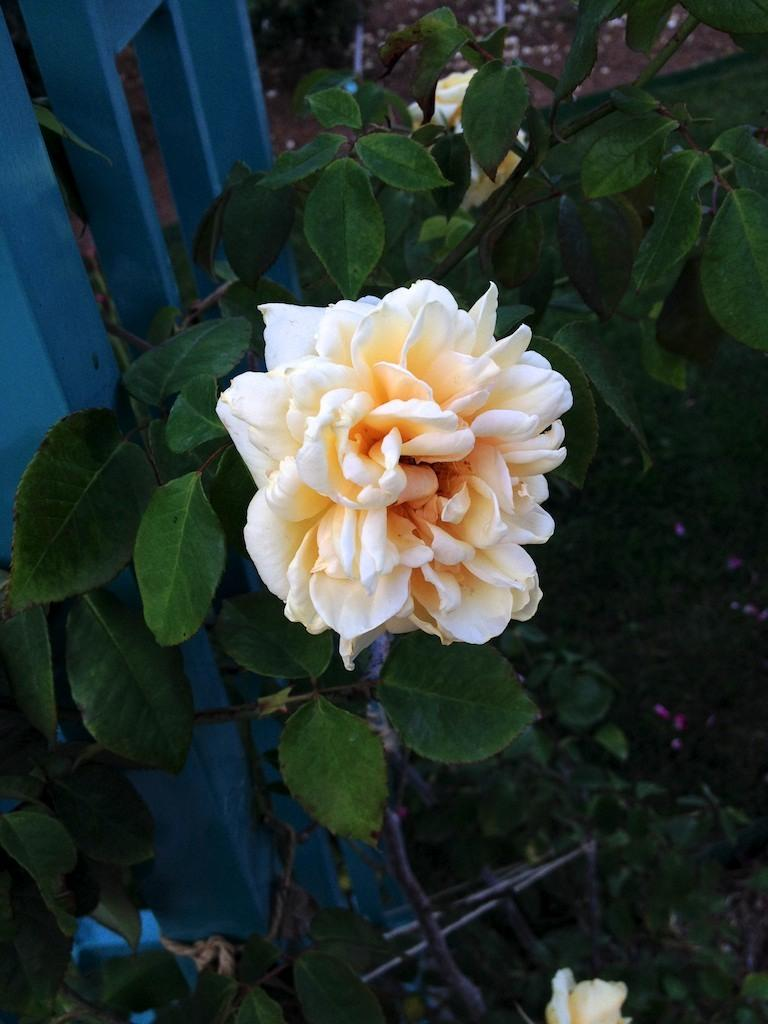What type of living organisms can be seen in the image? Flowers and plants can be seen in the image. Can you describe the plants in the image? The plants in the image are flowers. What type of jelly can be seen in the image? There is no jelly present in the image. What type of copper object is visible in the image? There is no copper object present in the image. 